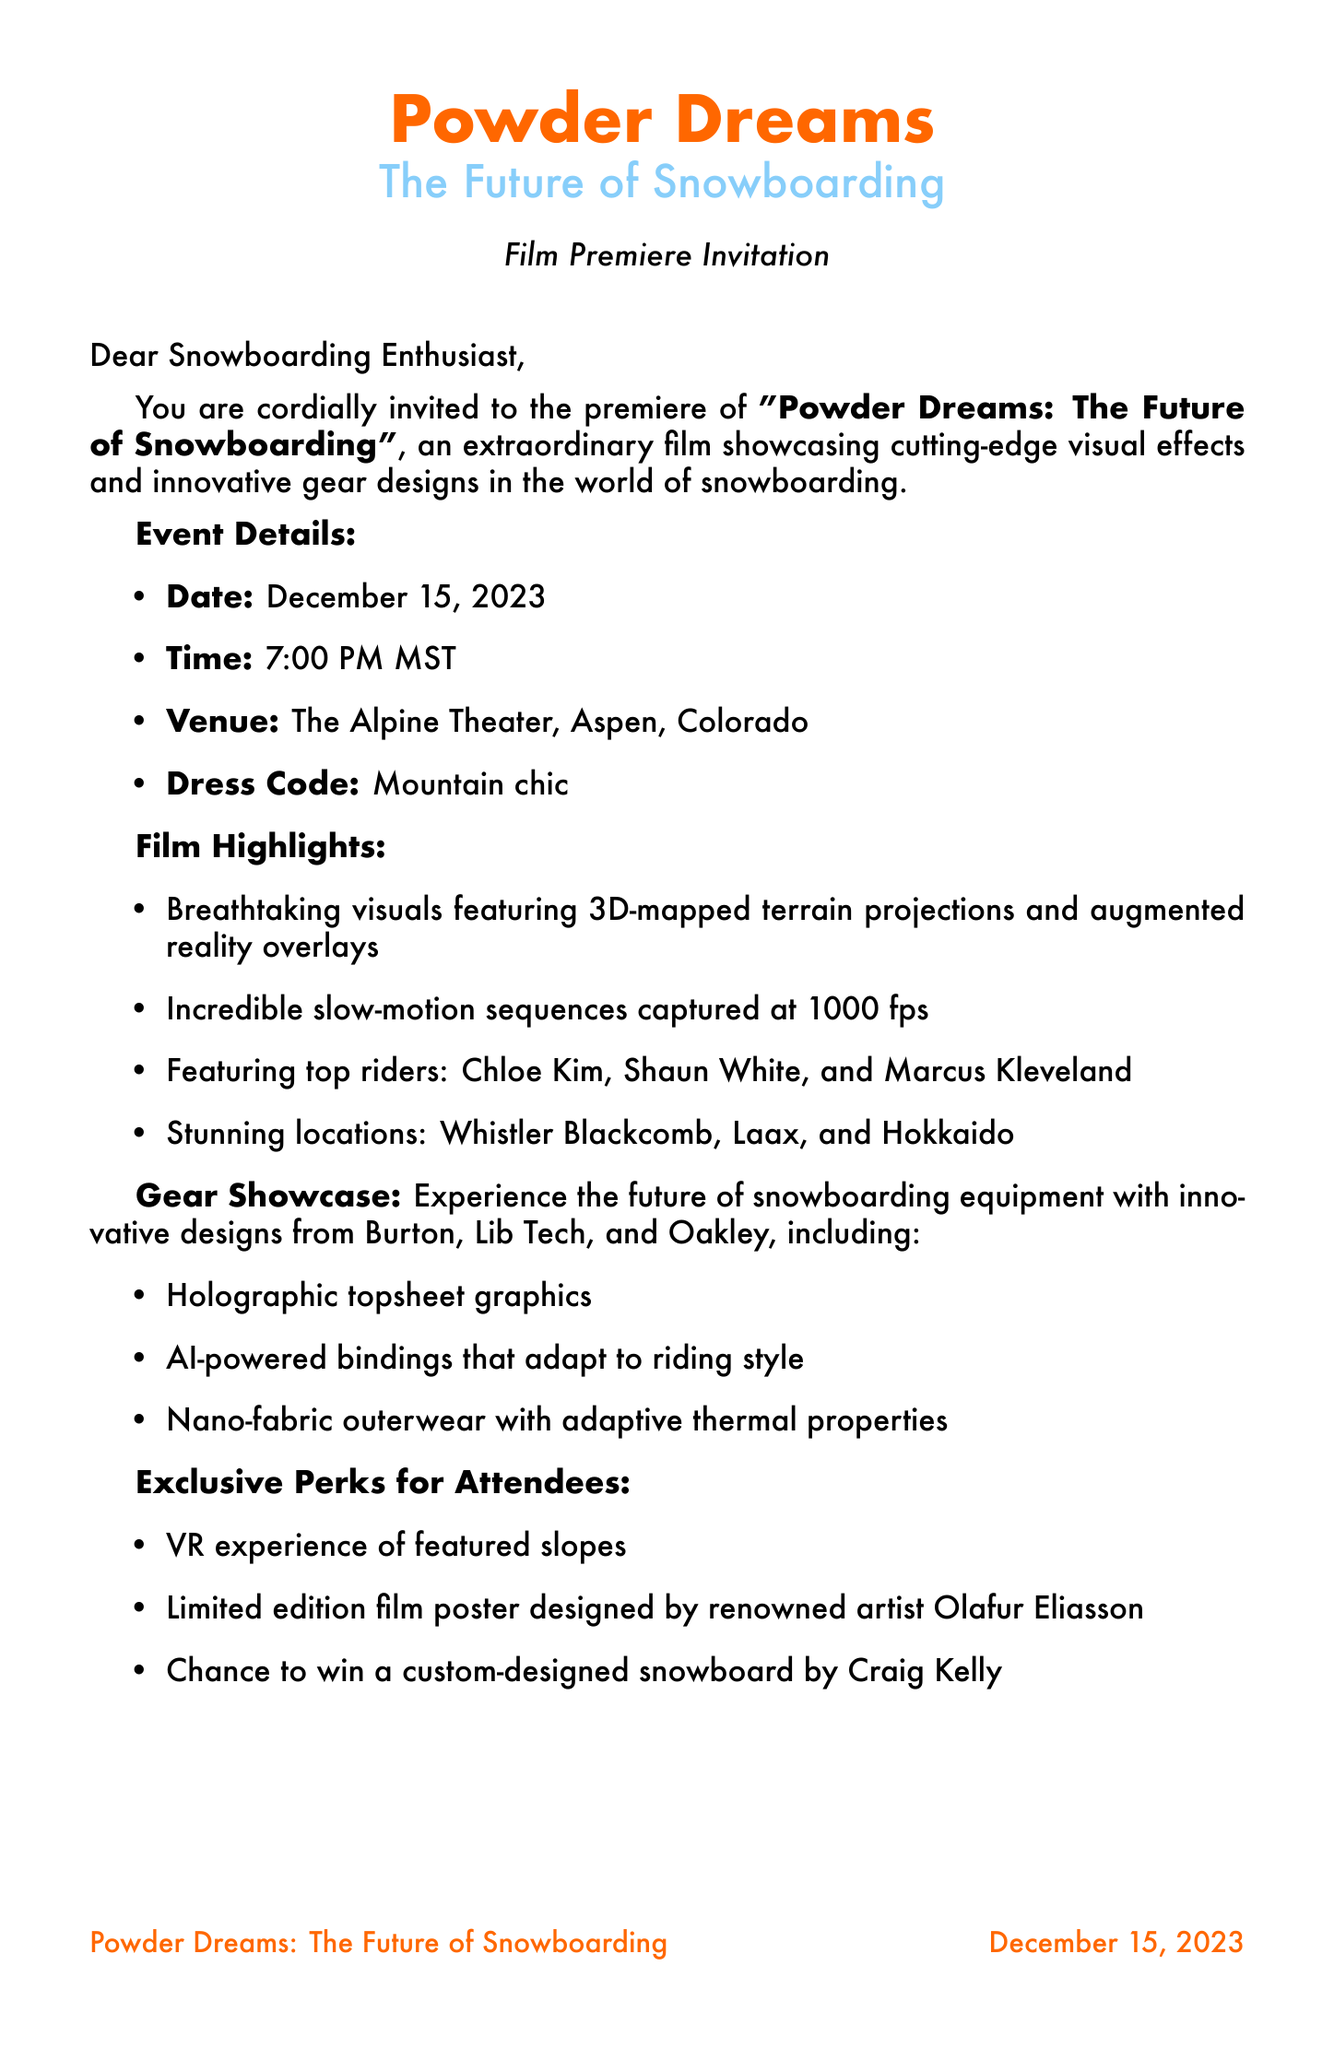what is the film title? The film title is mentioned in the event details of the invitation.
Answer: Powder Dreams: The Future of Snowboarding when is the premiere date? The premiere date is provided directly in the event details section.
Answer: December 15, 2023 where is the venue located? The venue location is specified in the event details section of the document.
Answer: The Alpine Theater, Aspen, Colorado what are the dress code requirements? The dress code is explicitly stated in the event details of the invitation.
Answer: Mountain chic which brand features innovative designs in the gear showcase? The gear showcase lists several brands that feature innovative designs.
Answer: Burton what is the unique feature of the AI-powered bindings? The description of the AI-powered bindings provides information about their functionality.
Answer: Adapt to riding style who is the artist for the limited edition film poster? The exclusive perks section mentions the artist for the film poster explicitly.
Answer: Olafur Eliasson what is the RSVP deadline? The RSVP deadline is given at the end of the invitation for confirmations.
Answer: December 1, 2023 which professional snowboarder is featured in the film? The featured riders section lists several names, including one prominent rider.
Answer: Chloe Kim 